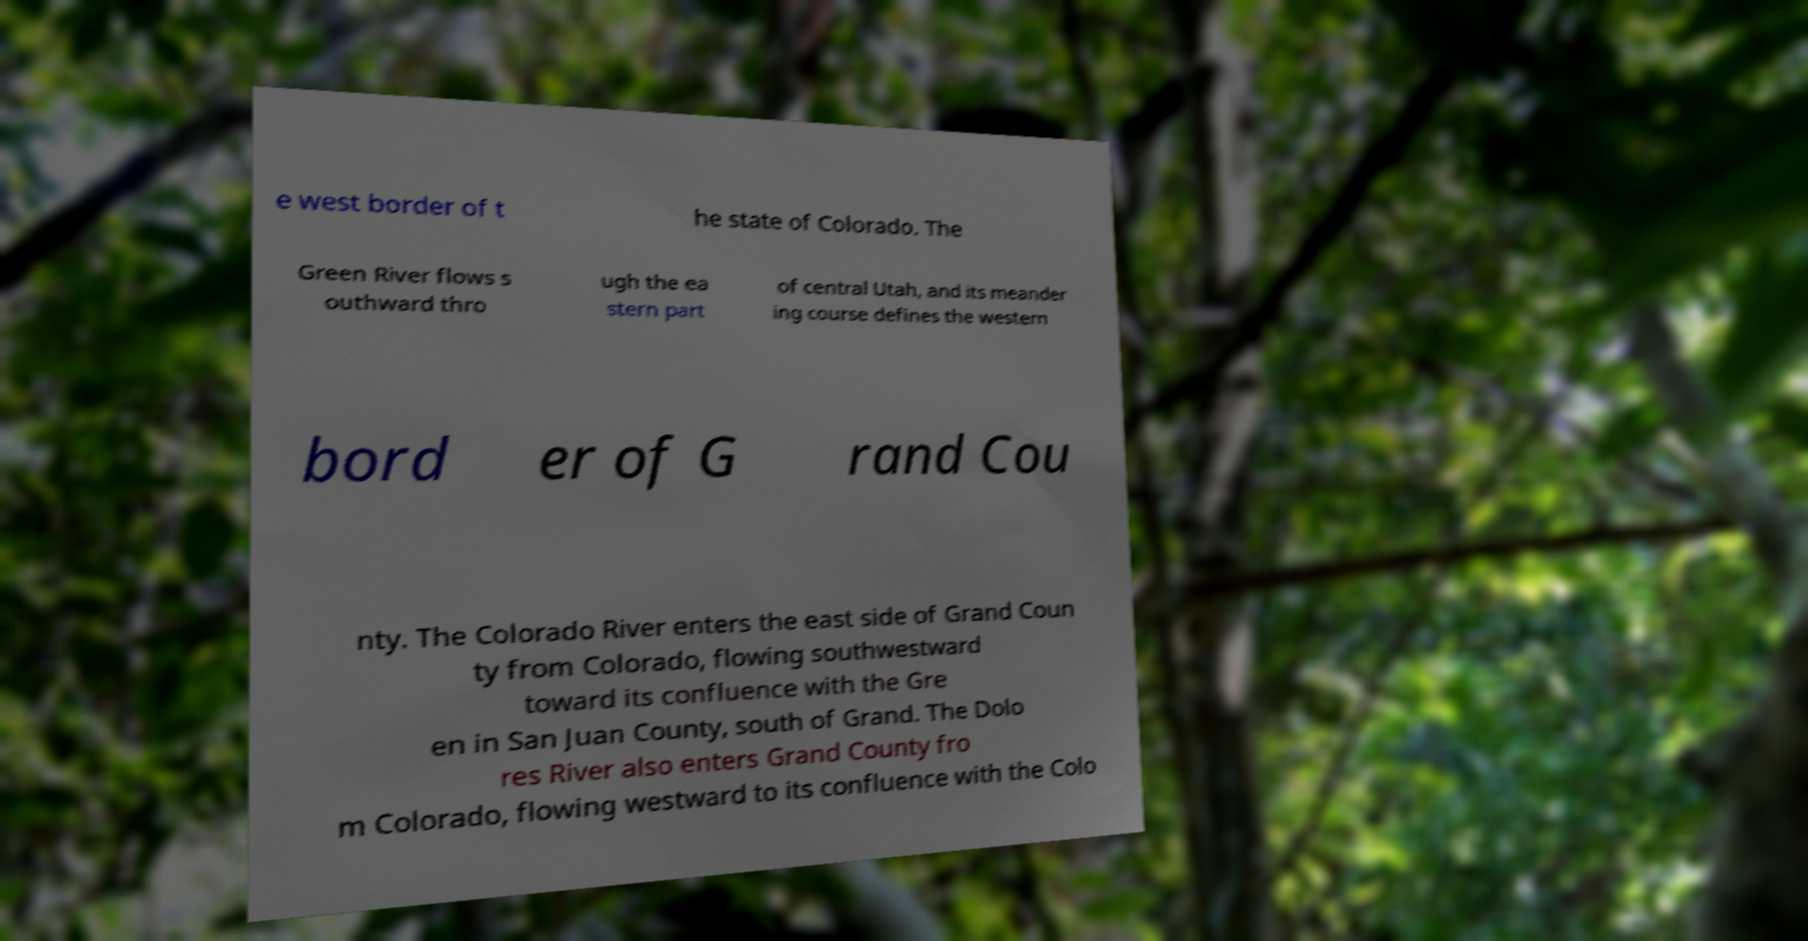Please identify and transcribe the text found in this image. e west border of t he state of Colorado. The Green River flows s outhward thro ugh the ea stern part of central Utah, and its meander ing course defines the western bord er of G rand Cou nty. The Colorado River enters the east side of Grand Coun ty from Colorado, flowing southwestward toward its confluence with the Gre en in San Juan County, south of Grand. The Dolo res River also enters Grand County fro m Colorado, flowing westward to its confluence with the Colo 